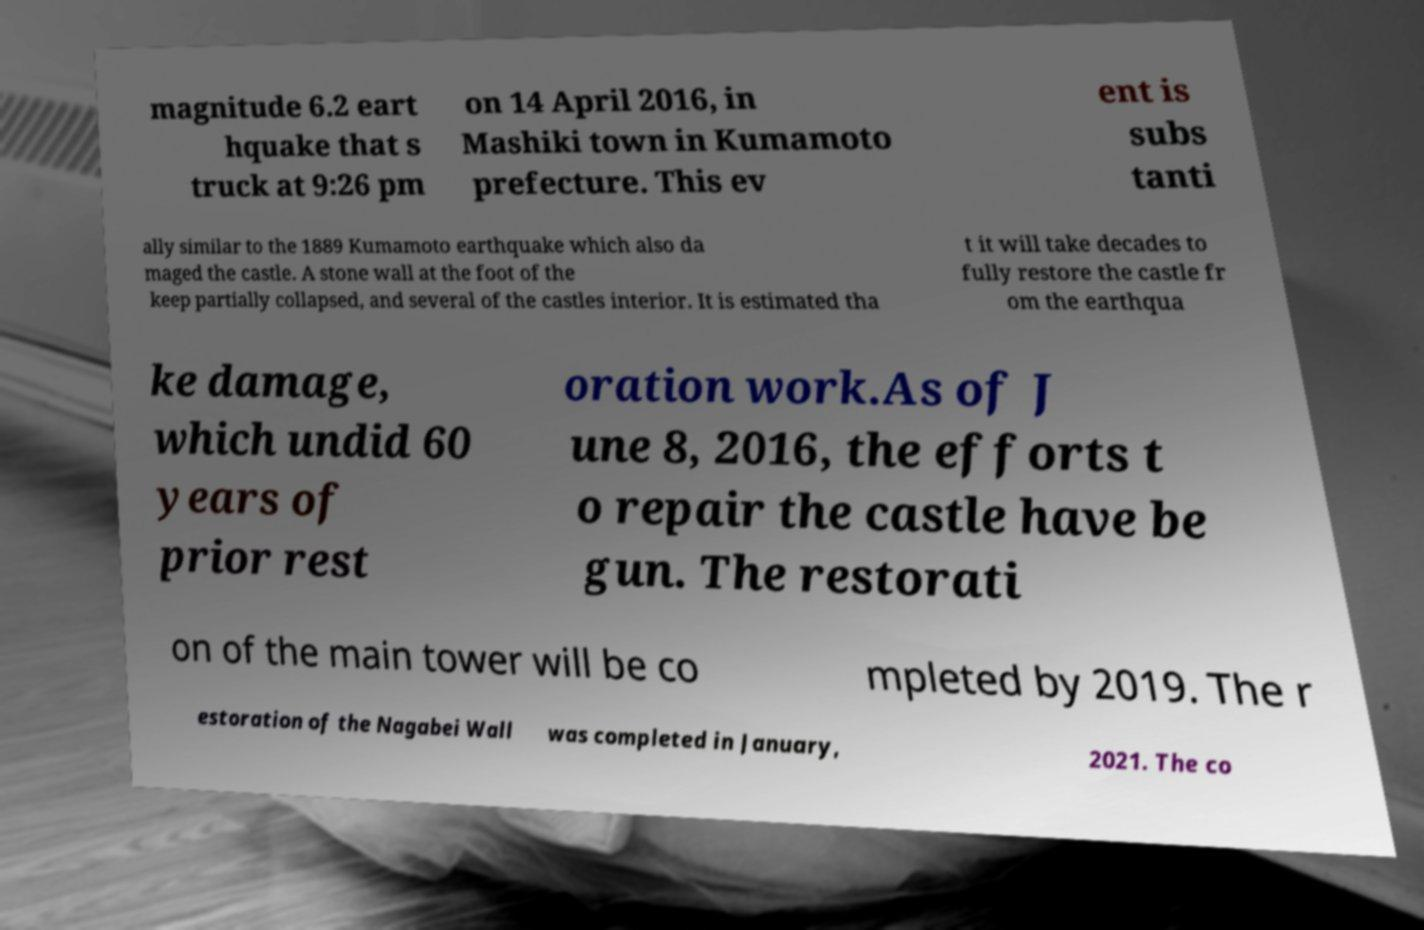What messages or text are displayed in this image? I need them in a readable, typed format. magnitude 6.2 eart hquake that s truck at 9:26 pm on 14 April 2016, in Mashiki town in Kumamoto prefecture. This ev ent is subs tanti ally similar to the 1889 Kumamoto earthquake which also da maged the castle. A stone wall at the foot of the keep partially collapsed, and several of the castles interior. It is estimated tha t it will take decades to fully restore the castle fr om the earthqua ke damage, which undid 60 years of prior rest oration work.As of J une 8, 2016, the efforts t o repair the castle have be gun. The restorati on of the main tower will be co mpleted by 2019. The r estoration of the Nagabei Wall was completed in January, 2021. The co 